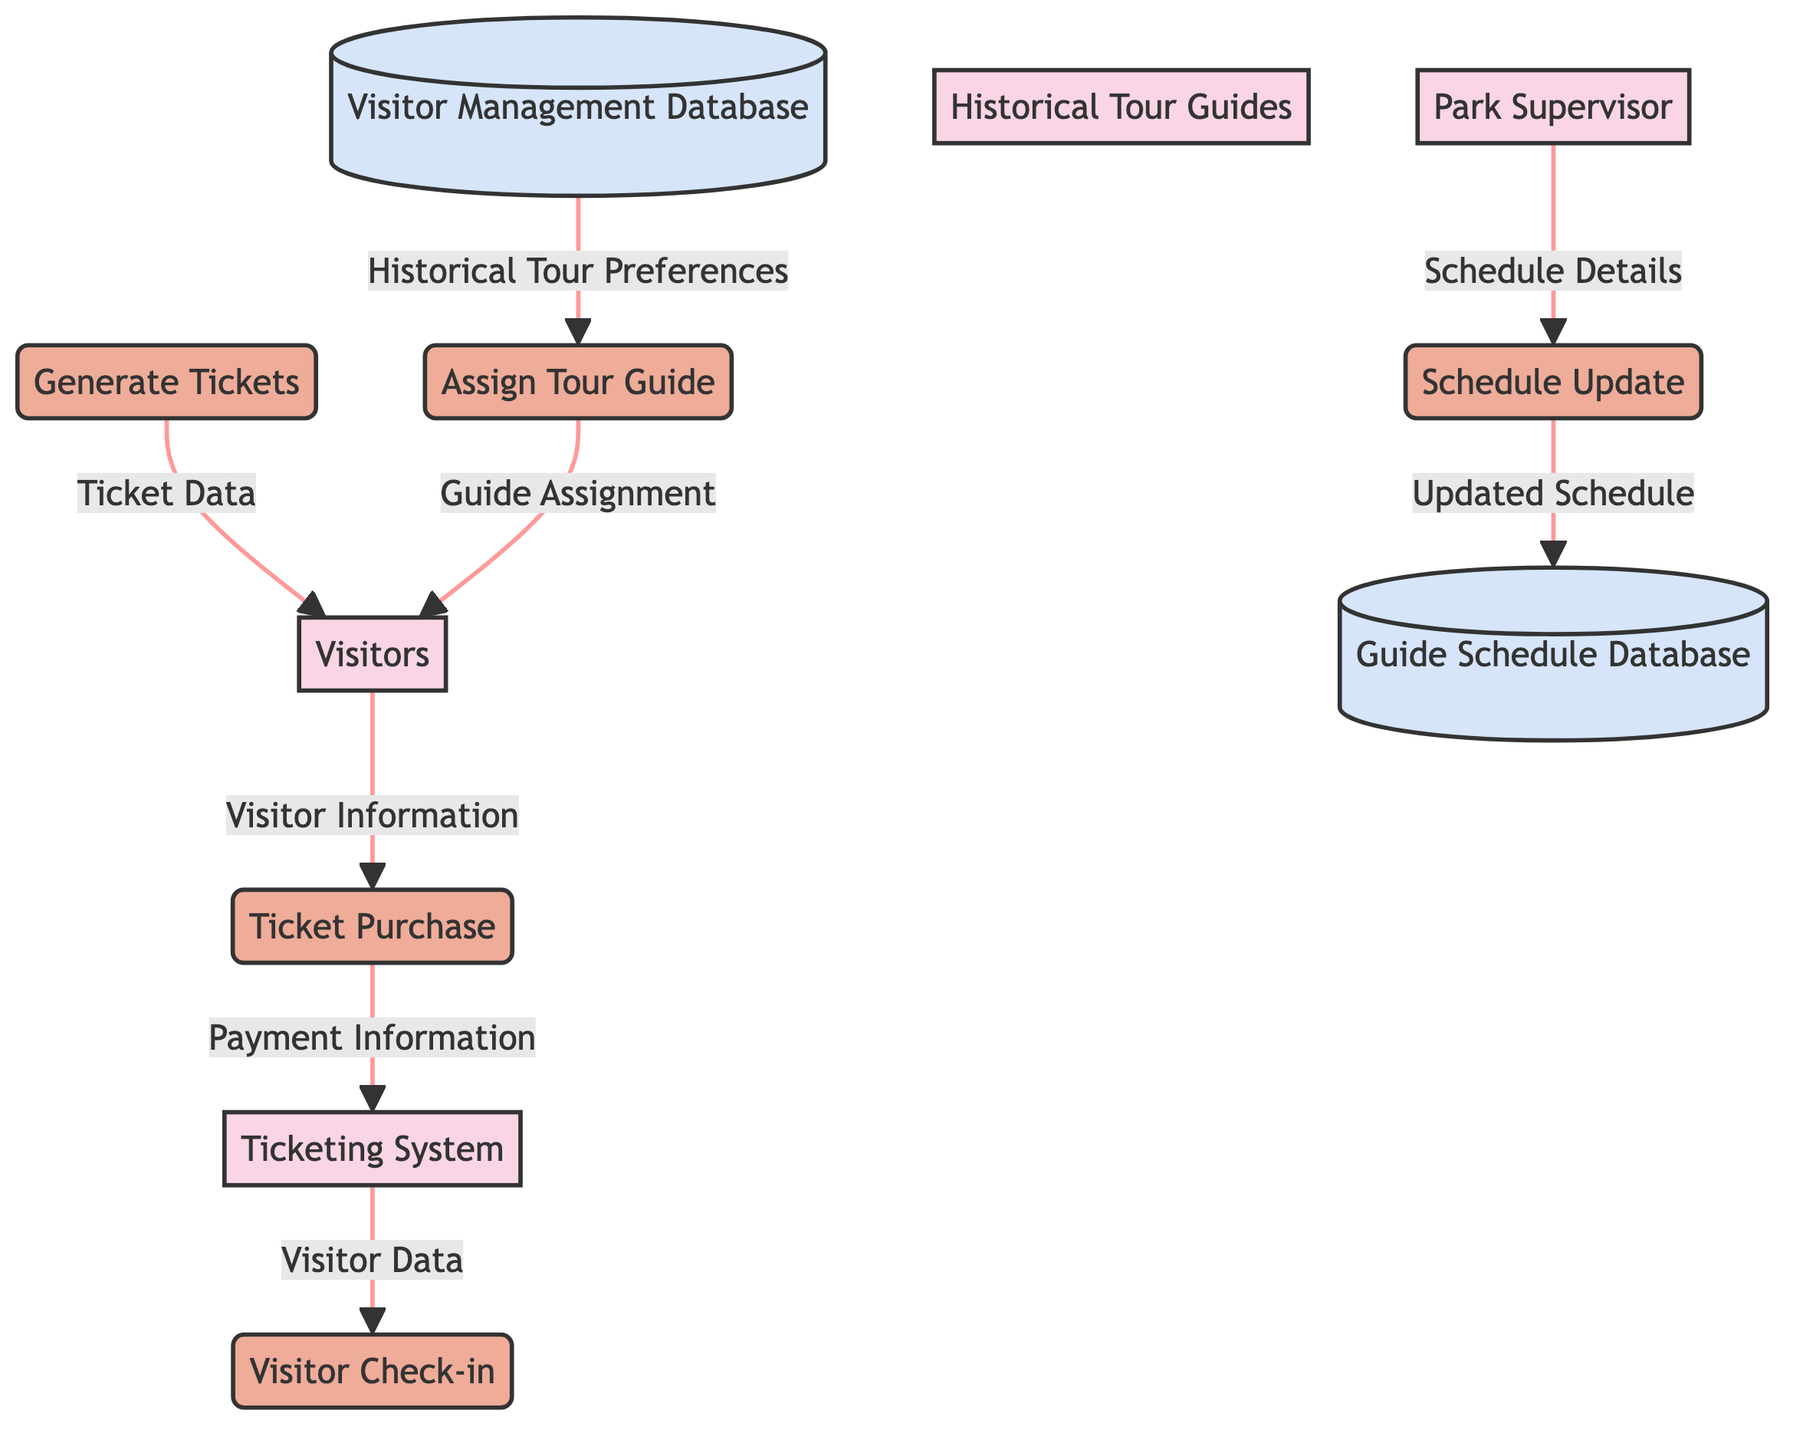What is the total number of entities in the diagram? There are six entities shown in the diagram: Park Supervisor, Visitors, Ticketing System, Historical Tour Guides, Guide Schedule Database, and Visitor Management Database. Counting these, we find a total of six entities.
Answer: 6 What process handles the payment details during a ticket purchase? The payment details are captured during the "Ticket Purchase" process, which is clearly indicated in the data flow diagram between Visitors and the Ticketing System.
Answer: Ticket Purchase How many data flows connect to the Visitors entity? The Visitors entity is connected to three data flows: "Visitor Information" to Ticket Purchase, "Guide Assignment" to Visitors, and "Ticket Data" from Generate Tickets. Counting these, we find three connections.
Answer: 3 Which process updates the guide schedule in the database? The process responsible for updating the guide schedule in the database is the "Schedule Update," which receives information from the Park Supervisor and updates the Guide Schedule Database.
Answer: Schedule Update What type of data is stored in the Visitor Management Database? The Visitor Management Database stores information about visitors and tickets, as indicated in its description. This implies it holds visitor data, ticket information, and preferences for historical tours.
Answer: Visitor information and tickets How is the tour guide assigned to visitors? The process called "Assign Tour Guide" assigns a historical tour guide to visitors based on both the guide schedule and the visitor's preferences as retrieved from the Visitor Management Database.
Answer: Assign Tour Guide What connects the Park Supervisor to the Guide Schedule Database? The connection between the Park Supervisor and the Guide Schedule Database is through the "Schedule Update" process. The Park Supervisor provides schedule details that are updated in the database.
Answer: Schedule Update Which process generates tickets for visitors? The process responsible for generating tickets is "Generate Tickets," as it is specifically named and linked to the Visitors entity through the data flow named "Ticket Data."
Answer: Generate Tickets What information flows from the Visitor Management Database to the Assign Tour Guide process? The information that flows from the Visitor Management Database to the Assign Tour Guide process is "Historical Tour Preferences," which informs the guide assignment process.
Answer: Historical Tour Preferences 